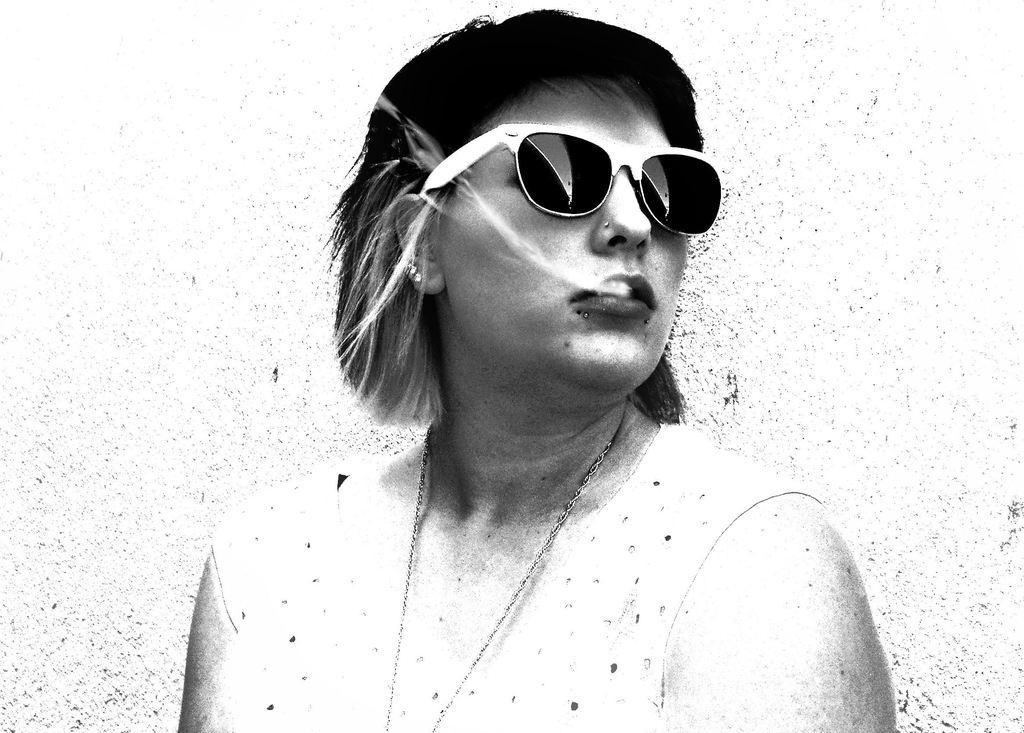What is the color scheme of the image? The image is black and white. Who is the main subject in the image? There is a lady in the center of the image. What is the lady wearing? The lady is wearing a dress, a chain, and goggles. What can be seen in the background of the image? There is a wall in the background of the image. How many spiders are crawling on the canvas in the image? There is no canvas or spiders present in the image. What is the lady doing to get the attention of the viewers in the image? The image does not provide any information about the lady's actions or intentions, so we cannot determine if she is trying to get the attention of the viewers. 